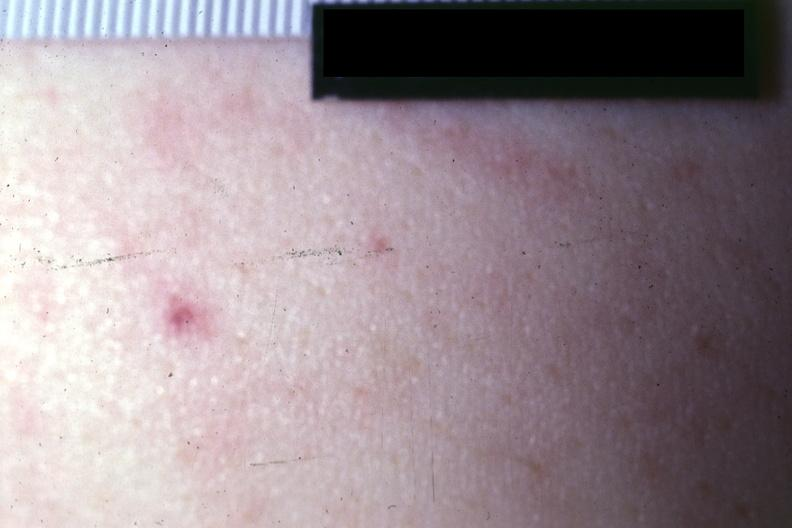where is this?
Answer the question using a single word or phrase. Skin 